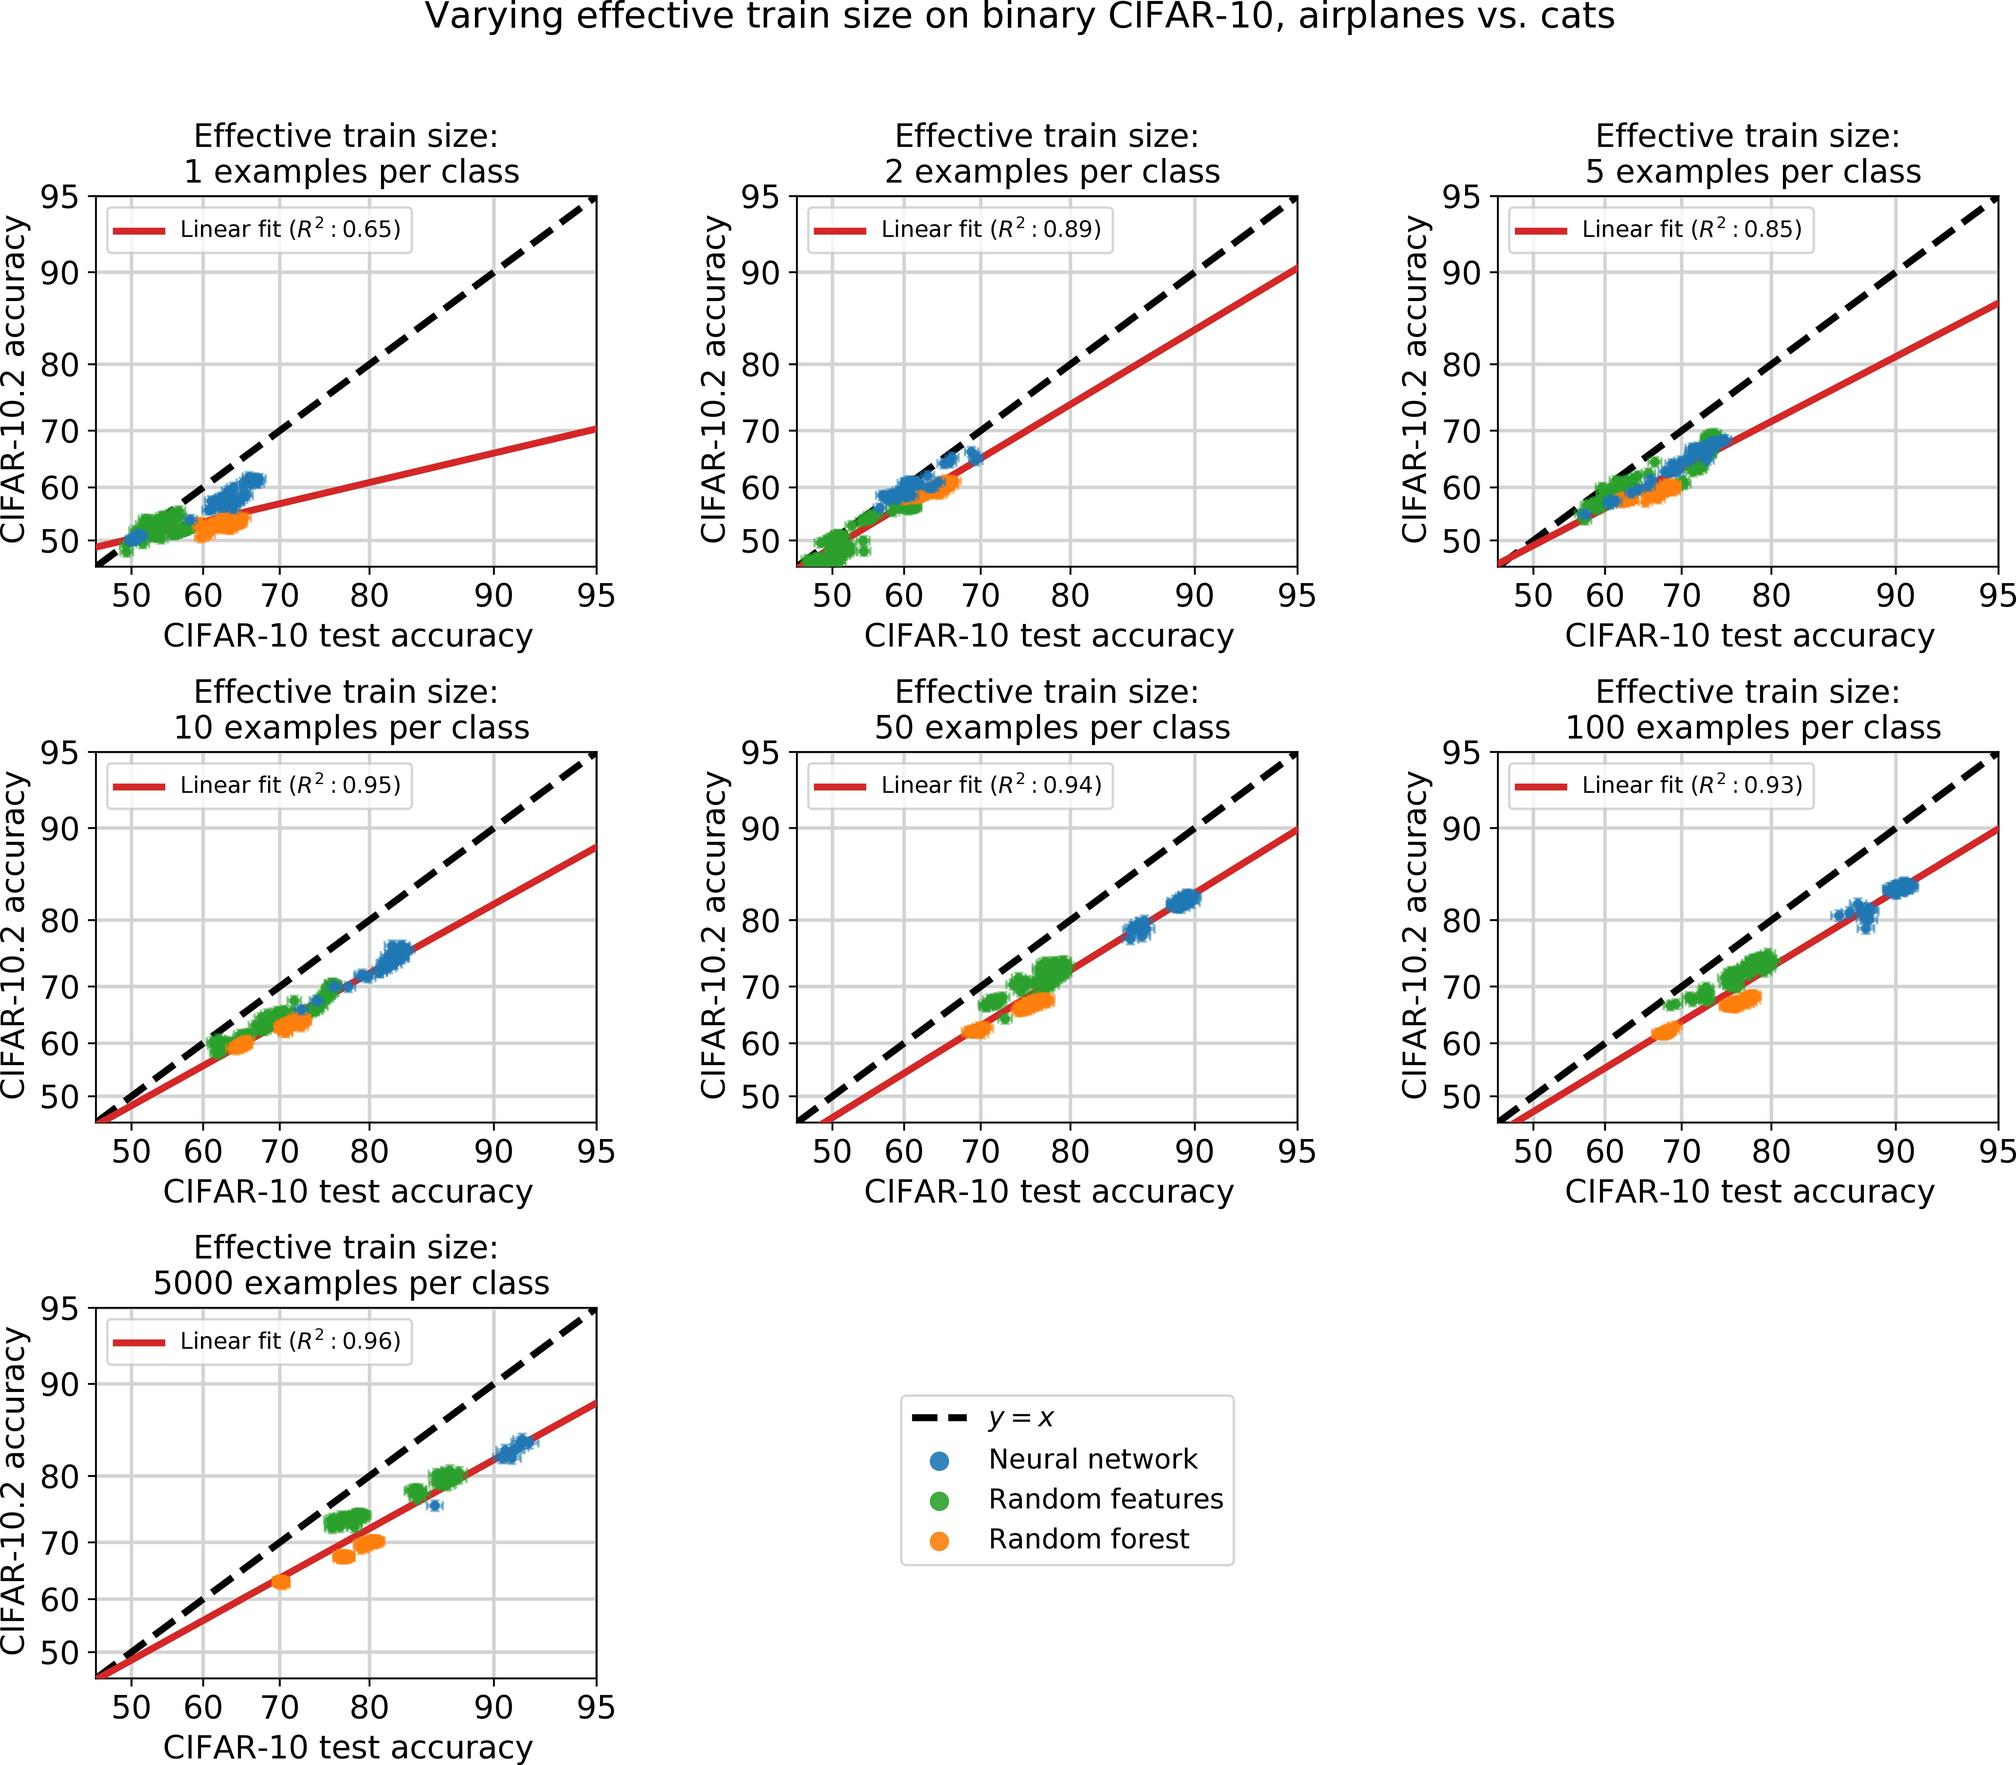Can you analyze the difference in performance impact between using neural networks and other methods such as random forests according to the provided graphs? In the graphs, neural networks generally show a steeper slope in their linear fit compared to random forests and random features, especially in configurations with higher numbers of examples per class. This suggests that neural networks are more sensitive to increases in training data size, potentially achieving higher accuracies more rapidly with additional training data. 